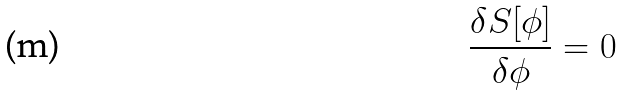Convert formula to latex. <formula><loc_0><loc_0><loc_500><loc_500>\frac { \delta S [ \phi ] } { \delta \phi } = 0</formula> 